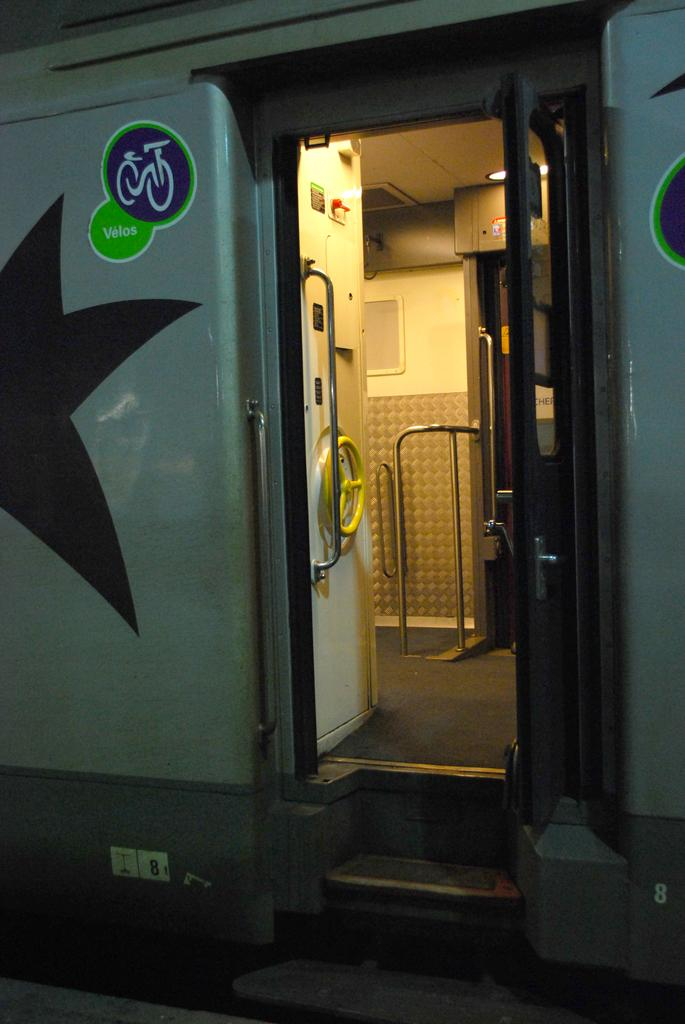What is the main subject of the image? The main subject of the image is a train. Can you describe any specific features of the train? There is a handle, a door, boards, a roof, a light, and a wall visible on the train in the image. What type of structure is present at the bottom of the image? There is a platform at the bottom of the image. Are there any architectural elements visible in the image? Yes, there are stairs and a floor visible in the image. What type of lead can be seen connecting the train to the platform in the image? There is no lead connecting the train to the platform in the image. What kind of jewel is adorning the train's roof in the image? There is no jewel present on the train's roof in the image. 